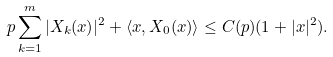<formula> <loc_0><loc_0><loc_500><loc_500>p \sum _ { k = 1 } ^ { m } | X _ { k } ( x ) | ^ { 2 } + \langle x , X _ { 0 } ( x ) \rangle \leq C ( p ) ( 1 + | x | ^ { 2 } ) .</formula> 